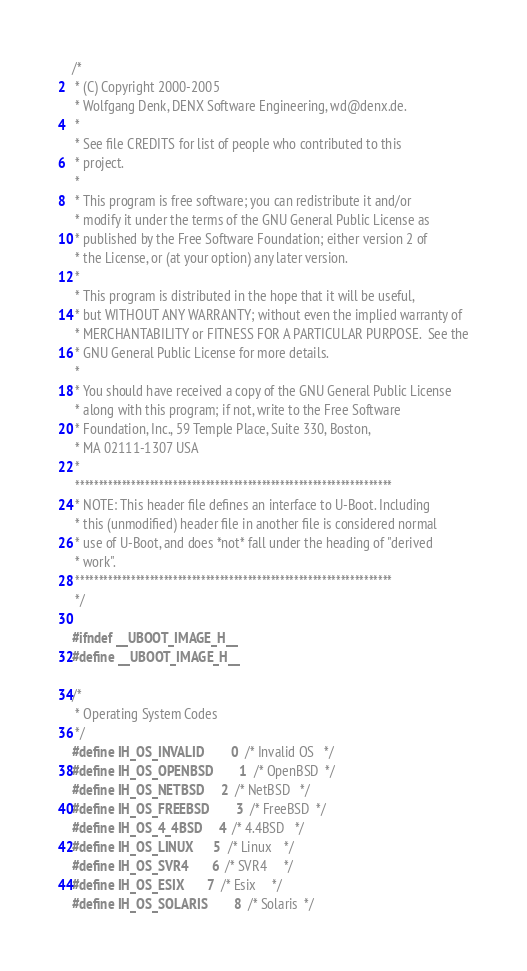<code> <loc_0><loc_0><loc_500><loc_500><_C_>/*
 * (C) Copyright 2000-2005
 * Wolfgang Denk, DENX Software Engineering, wd@denx.de.
 *
 * See file CREDITS for list of people who contributed to this
 * project.
 *
 * This program is free software; you can redistribute it and/or
 * modify it under the terms of the GNU General Public License as
 * published by the Free Software Foundation; either version 2 of
 * the License, or (at your option) any later version.
 *
 * This program is distributed in the hope that it will be useful,
 * but WITHOUT ANY WARRANTY; without even the implied warranty of
 * MERCHANTABILITY or FITNESS FOR A PARTICULAR PURPOSE.	 See the
 * GNU General Public License for more details.
 *
 * You should have received a copy of the GNU General Public License
 * along with this program; if not, write to the Free Software
 * Foundation, Inc., 59 Temple Place, Suite 330, Boston,
 * MA 02111-1307 USA
 *
 ********************************************************************
 * NOTE: This header file defines an interface to U-Boot. Including
 * this (unmodified) header file in another file is considered normal
 * use of U-Boot, and does *not* fall under the heading of "derived
 * work".
 ********************************************************************
 */

#ifndef __UBOOT_IMAGE_H__
#define __UBOOT_IMAGE_H__

/*
 * Operating System Codes
 */
#define IH_OS_INVALID		0	/* Invalid OS	*/
#define IH_OS_OPENBSD		1	/* OpenBSD	*/
#define IH_OS_NETBSD		2	/* NetBSD	*/
#define IH_OS_FREEBSD		3	/* FreeBSD	*/
#define IH_OS_4_4BSD		4	/* 4.4BSD	*/
#define IH_OS_LINUX		5	/* Linux	*/
#define IH_OS_SVR4		6	/* SVR4		*/
#define IH_OS_ESIX		7	/* Esix		*/
#define IH_OS_SOLARIS		8	/* Solaris	*/</code> 